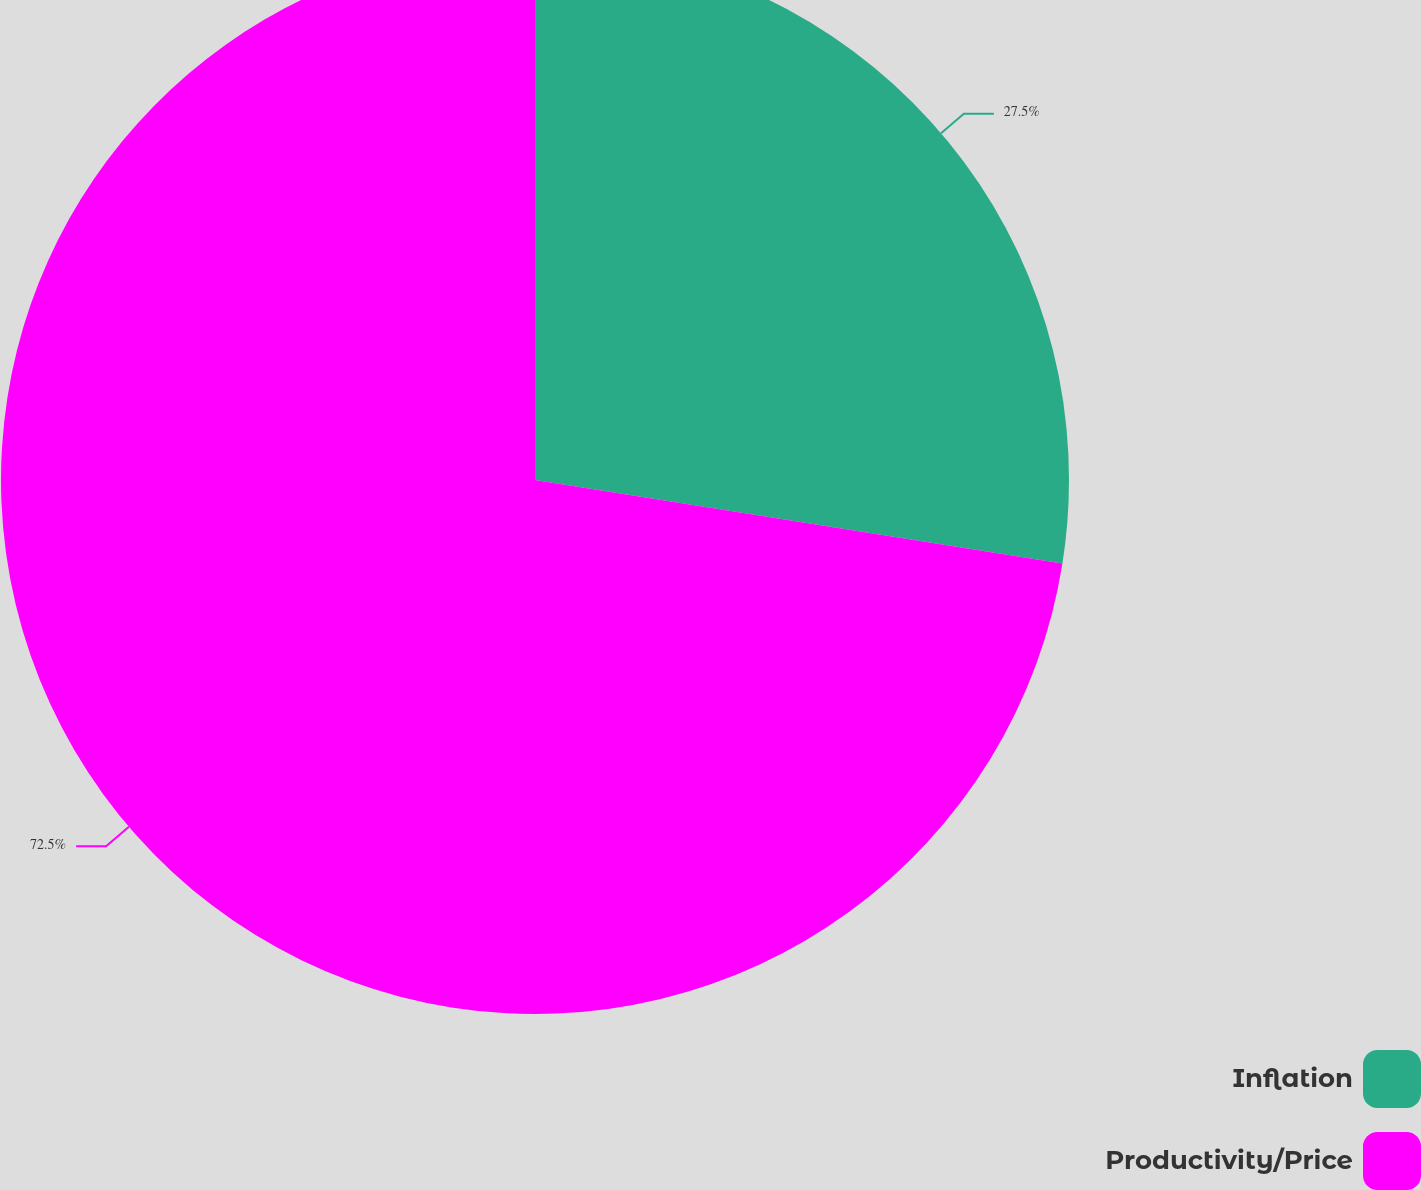Convert chart. <chart><loc_0><loc_0><loc_500><loc_500><pie_chart><fcel>Inflation<fcel>Productivity/Price<nl><fcel>27.5%<fcel>72.5%<nl></chart> 